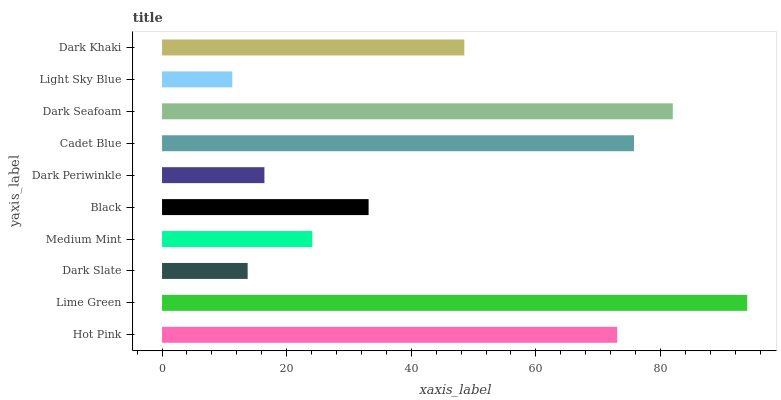Is Light Sky Blue the minimum?
Answer yes or no. Yes. Is Lime Green the maximum?
Answer yes or no. Yes. Is Dark Slate the minimum?
Answer yes or no. No. Is Dark Slate the maximum?
Answer yes or no. No. Is Lime Green greater than Dark Slate?
Answer yes or no. Yes. Is Dark Slate less than Lime Green?
Answer yes or no. Yes. Is Dark Slate greater than Lime Green?
Answer yes or no. No. Is Lime Green less than Dark Slate?
Answer yes or no. No. Is Dark Khaki the high median?
Answer yes or no. Yes. Is Black the low median?
Answer yes or no. Yes. Is Dark Seafoam the high median?
Answer yes or no. No. Is Light Sky Blue the low median?
Answer yes or no. No. 